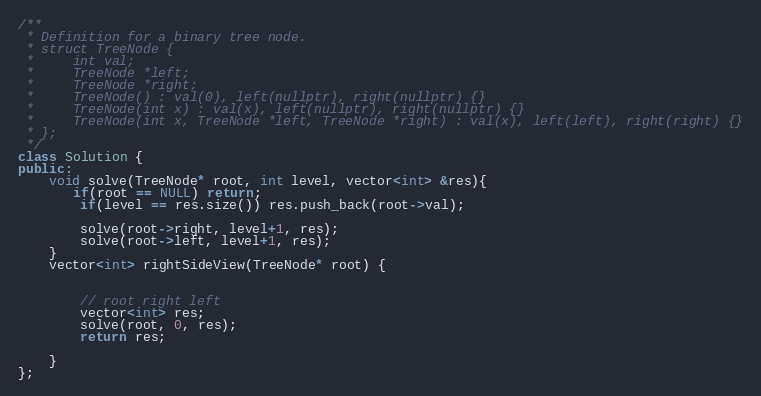<code> <loc_0><loc_0><loc_500><loc_500><_C++_>/**
 * Definition for a binary tree node.
 * struct TreeNode {
 *     int val;
 *     TreeNode *left;
 *     TreeNode *right;
 *     TreeNode() : val(0), left(nullptr), right(nullptr) {}
 *     TreeNode(int x) : val(x), left(nullptr), right(nullptr) {}
 *     TreeNode(int x, TreeNode *left, TreeNode *right) : val(x), left(left), right(right) {}
 * };
 */
class Solution {
public:
    void solve(TreeNode* root, int level, vector<int> &res){
       if(root == NULL) return;
        if(level == res.size()) res.push_back(root->val);
        
        solve(root->right, level+1, res);
        solve(root->left, level+1, res);
    }
    vector<int> rightSideView(TreeNode* root) {
        
        
        // root right left
        vector<int> res;
        solve(root, 0, res);
        return res;
        
    }
};</code> 